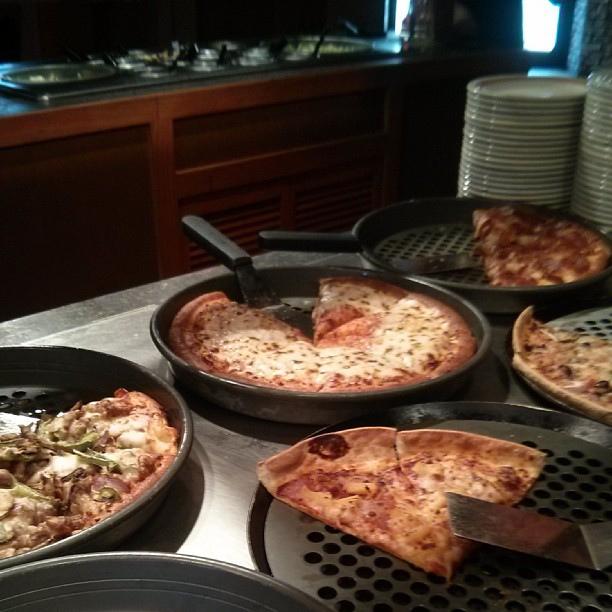Where is the salad bar?
Short answer required. In back. Is this at a restaurant?
Short answer required. Yes. How many slices of pizza are left on the closest pan?
Quick response, please. 2. 